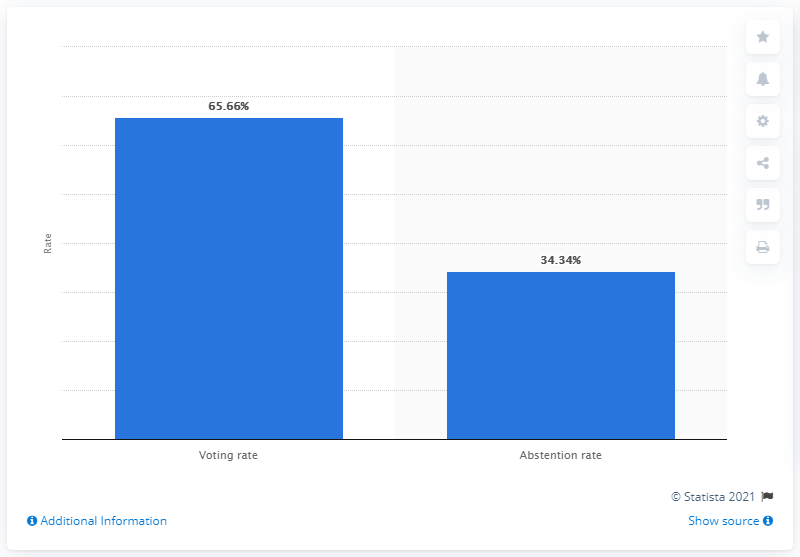Outline some significant characteristics in this image. Out of the total number of registered voters in the 2018 primaries, 65.66% cast a vote. According to the data, 34.34% of the Costa Rican electorate did not participate in the voting process. 